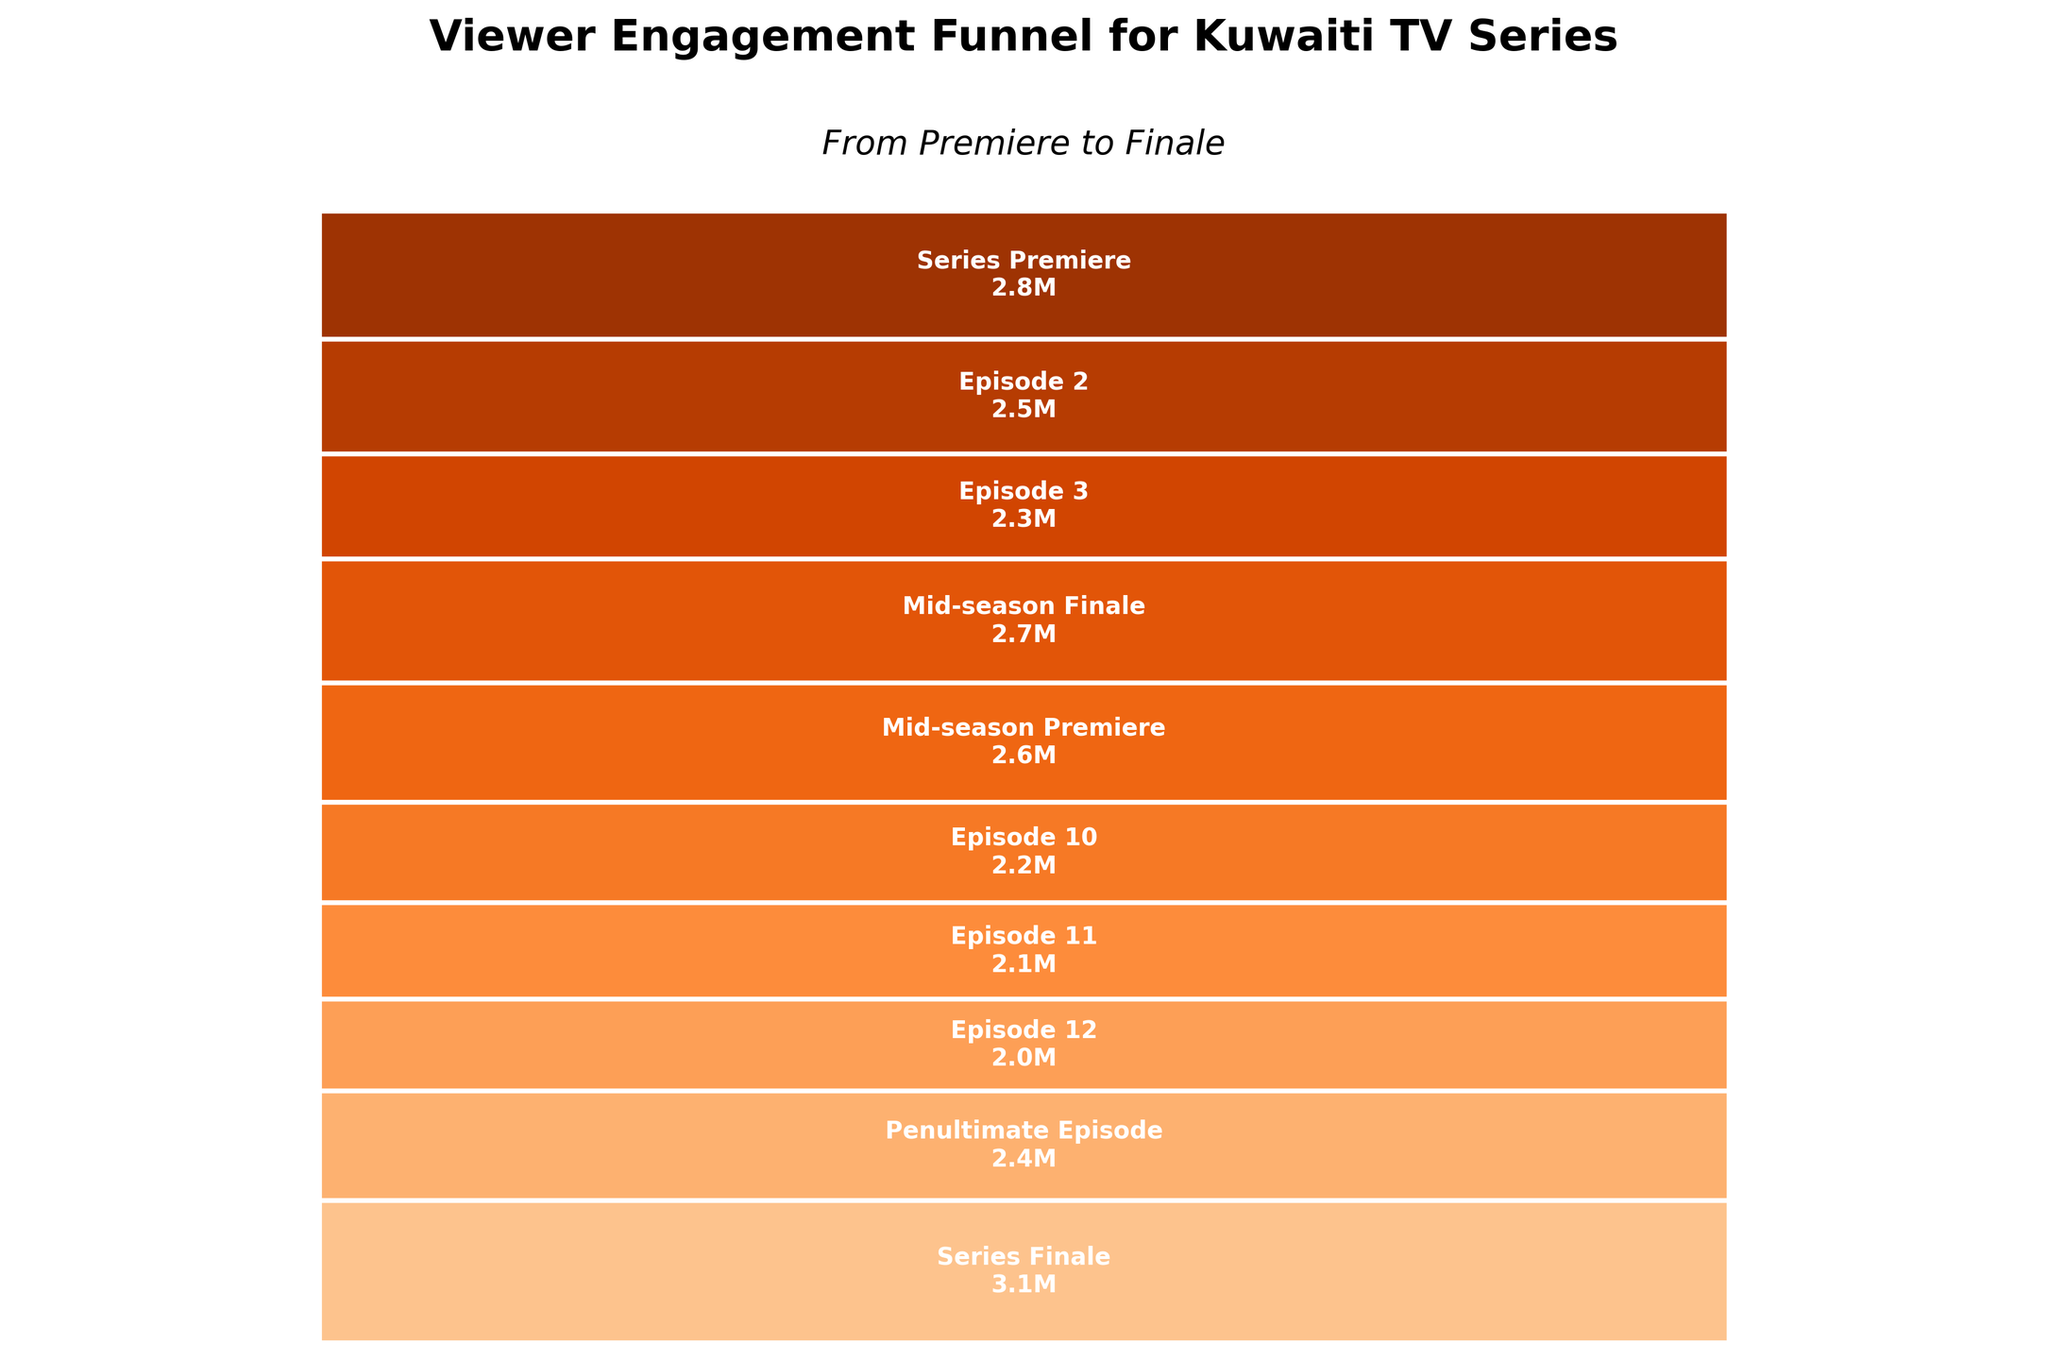Which episode had the highest viewer engagement? The Series Finale had the highest viewer engagement with 3.1 million viewers.
Answer: Series Finale How many viewers did the Series Premiere have? The Series Premiere had 2.8 million viewers. This information is located in the corresponding segment on the chart.
Answer: 2.8 million Which episode had the lowest viewer engagement? Episode 12 had the lowest viewer engagement with 2.0 million viewers. This information is found by checking the smallest segment in the funnel chart.
Answer: Episode 12 How much did viewer engagement increase from the Penultimate Episode to the Series Finale? The Series Finale had 3.1 million viewers, and the Penultimate Episode had 2.4 million viewers. The increase is 3.1 - 2.4 = 0.7 million viewers.
Answer: 0.7 million What is the total viewer engagement from the Series Premiere to the Series Finale? Adding up all the viewers from each episode: 2.8 + 2.5 + 2.3 + 2.7 + 2.6 + 2.2 + 2.1 + 2.0 + 2.4 + 3.1 = 24.7 million viewers.
Answer: 24.7 million Which episode had more viewers, Episode 3 or Episode 10? Episode 3 had 2.3 million viewers, and Episode 10 had 2.2 million viewers. Therefore, Episode 3 had more viewers than Episode 10.
Answer: Episode 3 Did the viewer engagement generally increase or decrease toward the middle of the season? Viewer engagement decreased from the Series Premiere (2.8) to Episode 3 (2.3) but increased again towards the Mid-season Finale (2.7).
Answer: Decreased then increased What's the average viewer engagement across all episodes? Sum of all viewers: 24.7 million. Number of episodes: 10. Average viewer engagement: 24.7/10 = 2.47 million viewers.
Answer: 2.47 million How much did viewer engagement change from the Mid-season Premiere to Episode 12? Mid-season Premiere had 2.6 million viewers, Episode 12 had 2.0 million viewers. The change is 2.6 - 2.0 = 0.6 million viewers.
Answer: 0.6 million What is the color scheme used for the funnel segments? The funnel segments use shades of orange, starting from lighter to darker shades from top to bottom. This is inferred by noticing the gradient of orange colors used in the chart segments.
Answer: Shades of orange 